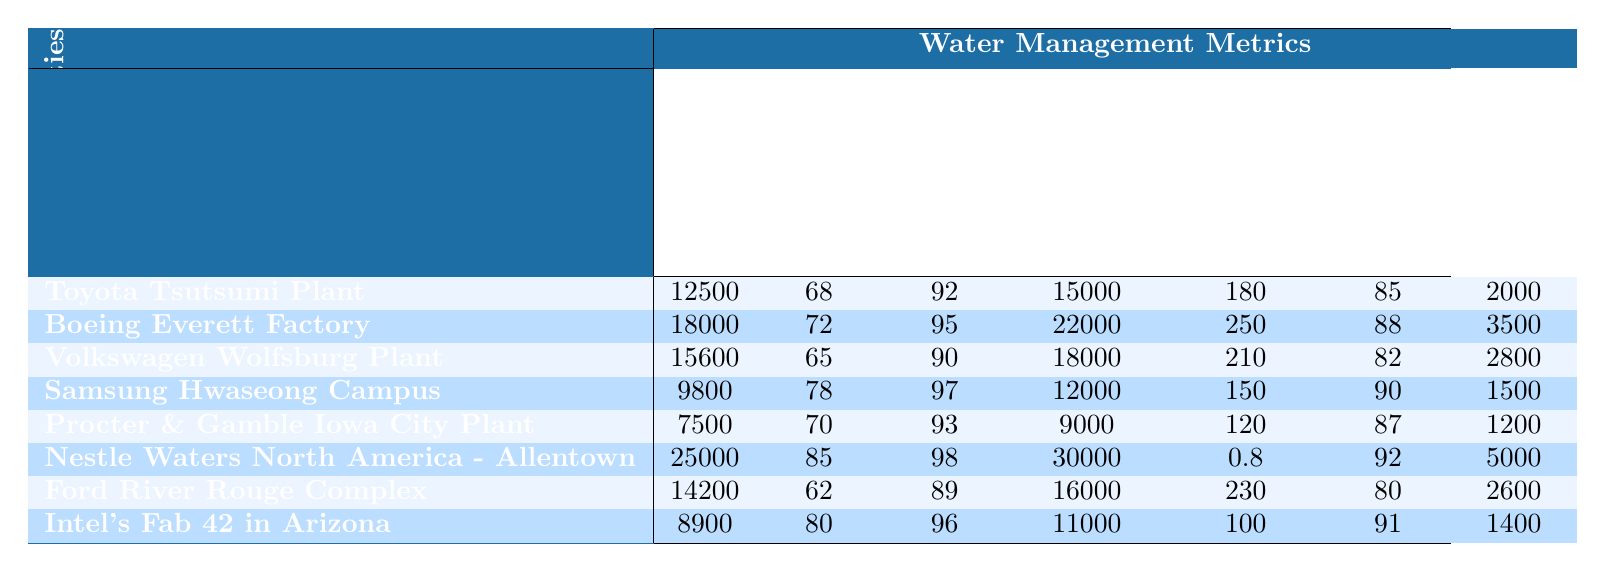What is the daily water usage of the Nestle Waters North America - Allentown facility? From the table, the daily water usage for the Nestle Waters North America - Allentown facility is listed as 25,000 m³.
Answer: 25,000 m³ Which facility has the highest annual water recycling rate? By examining the "Annual Water Recycling Rate (%)" column, the Nestle Waters North America - Allentown facility has the highest value at 85%.
Answer: 85% What is the water usage per unit produced at the Samsung Hwaseong Campus? The table lists the water usage per unit produced at the Samsung Hwaseong Campus as 150 L/unit.
Answer: 150 L/unit Which manufacturing facility has the lowest groundwater extraction? The Ford River Rouge Complex has the lowest groundwater extraction value of 2,600 m³/day.
Answer: 1,500 m³/day What is the average daily water usage across all facilities? Summing the daily water usage values: 12,500 + 18,000 + 15,600 + 9,800 + 7,500 + 25,000 + 14,200 + 8,900 = 91,500 m³. Dividing by 8 facilities gives an average of 11,437.5 m³.
Answer: 11,437.5 m³ Is the wastewater treatment efficiency at the Boeing Everett Factory above 90%? The table shows that the Boeing Everett Factory has a wastewater treatment efficiency of 95%, which is indeed above 90%.
Answer: Yes How much more daily water is used at the Intel's Fab 42 in Arizona compared to the Procter & Gamble Iowa City Plant? Daily water usage at Intel's Fab 42 is 8,900 m³ while at Procter & Gamble it is 7,500 m³. The difference is 8,900 - 7,500 = 1,400 m³.
Answer: 1,400 m³ What percentage of the total daily water usage is accounted for by the facility with the highest consumption? The facility with the highest daily water usage is Nestle Waters North America - Allentown at 25,000 m³. Total usage is 91,500 m³, so the percentage is (25,000 / 91,500) * 100 ≈ 27.3%.
Answer: 27.3% Which facility has the highest cooling tower water efficiency, and what is the value? The Nestle Waters North America - Allentown has a cooling tower water efficiency of 92%.
Answer: 92% If the daily water usage at the Volkswagen Wolfsburg Plant increases by 10%, what would the new value be? The current daily water usage at Volkswagen Wolfsburg Plant is 15,600 m³. A 10% increase would be 15,600 * 0.10 = 1,560 m³, making the new usage 15,600 + 1,560 = 17,160 m³.
Answer: 17,160 m³ 